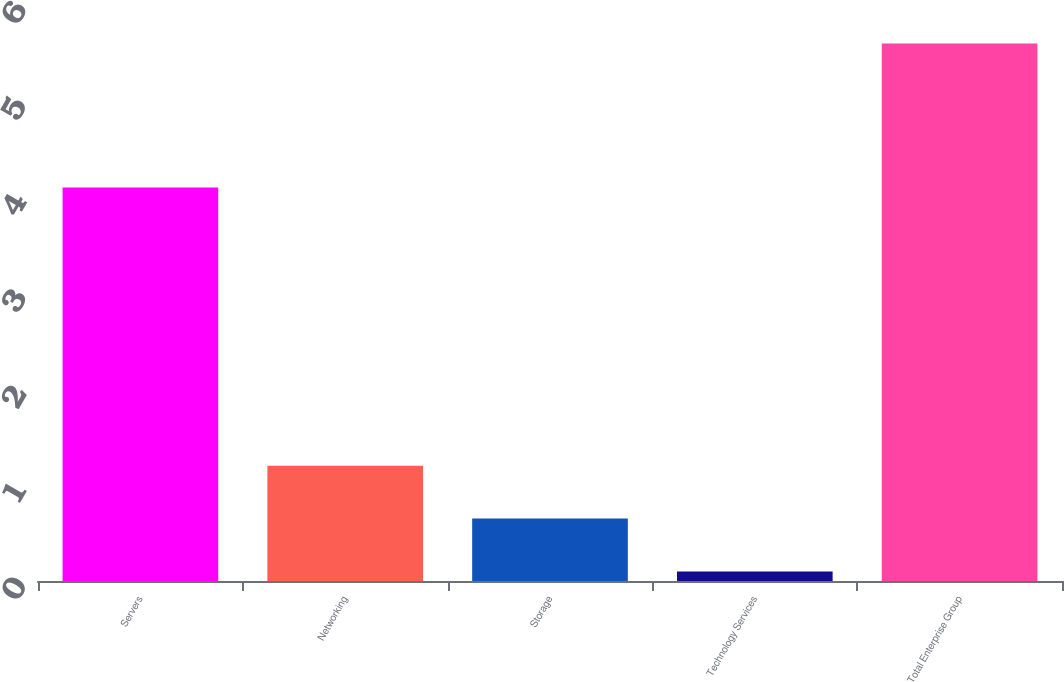<chart> <loc_0><loc_0><loc_500><loc_500><bar_chart><fcel>Servers<fcel>Networking<fcel>Storage<fcel>Technology Services<fcel>Total Enterprise Group<nl><fcel>4.1<fcel>1.2<fcel>0.65<fcel>0.1<fcel>5.6<nl></chart> 